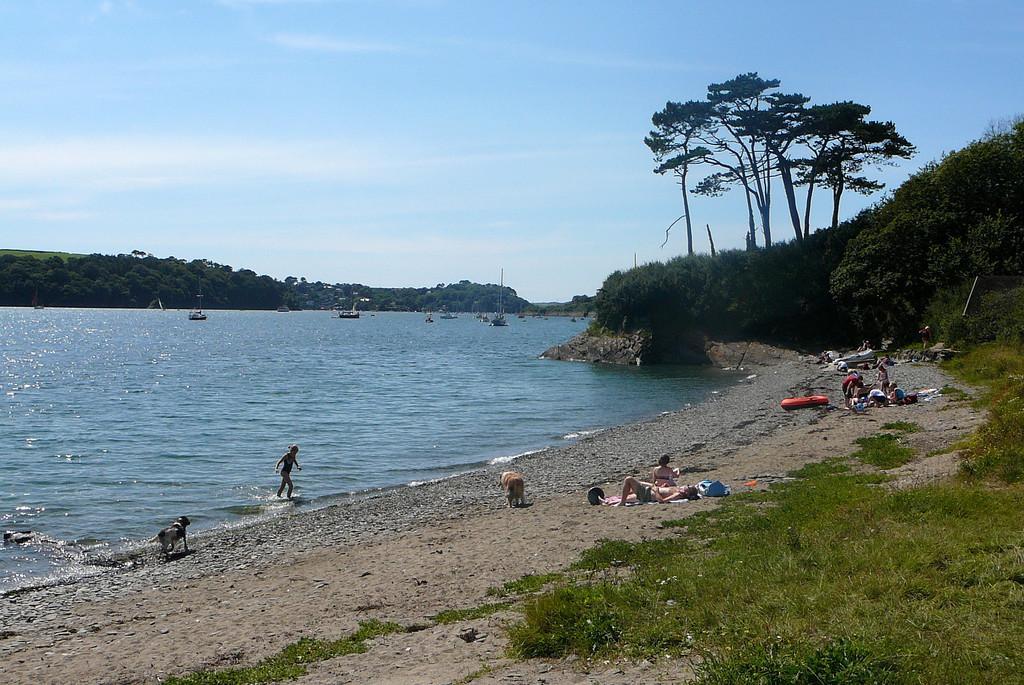Describe this image in one or two sentences. In the image there is a beach on the left side and on right side people are lying on the land and standing, there are trees on the grassland, in the back there are ships in the ocean and above its sky with clouds. 